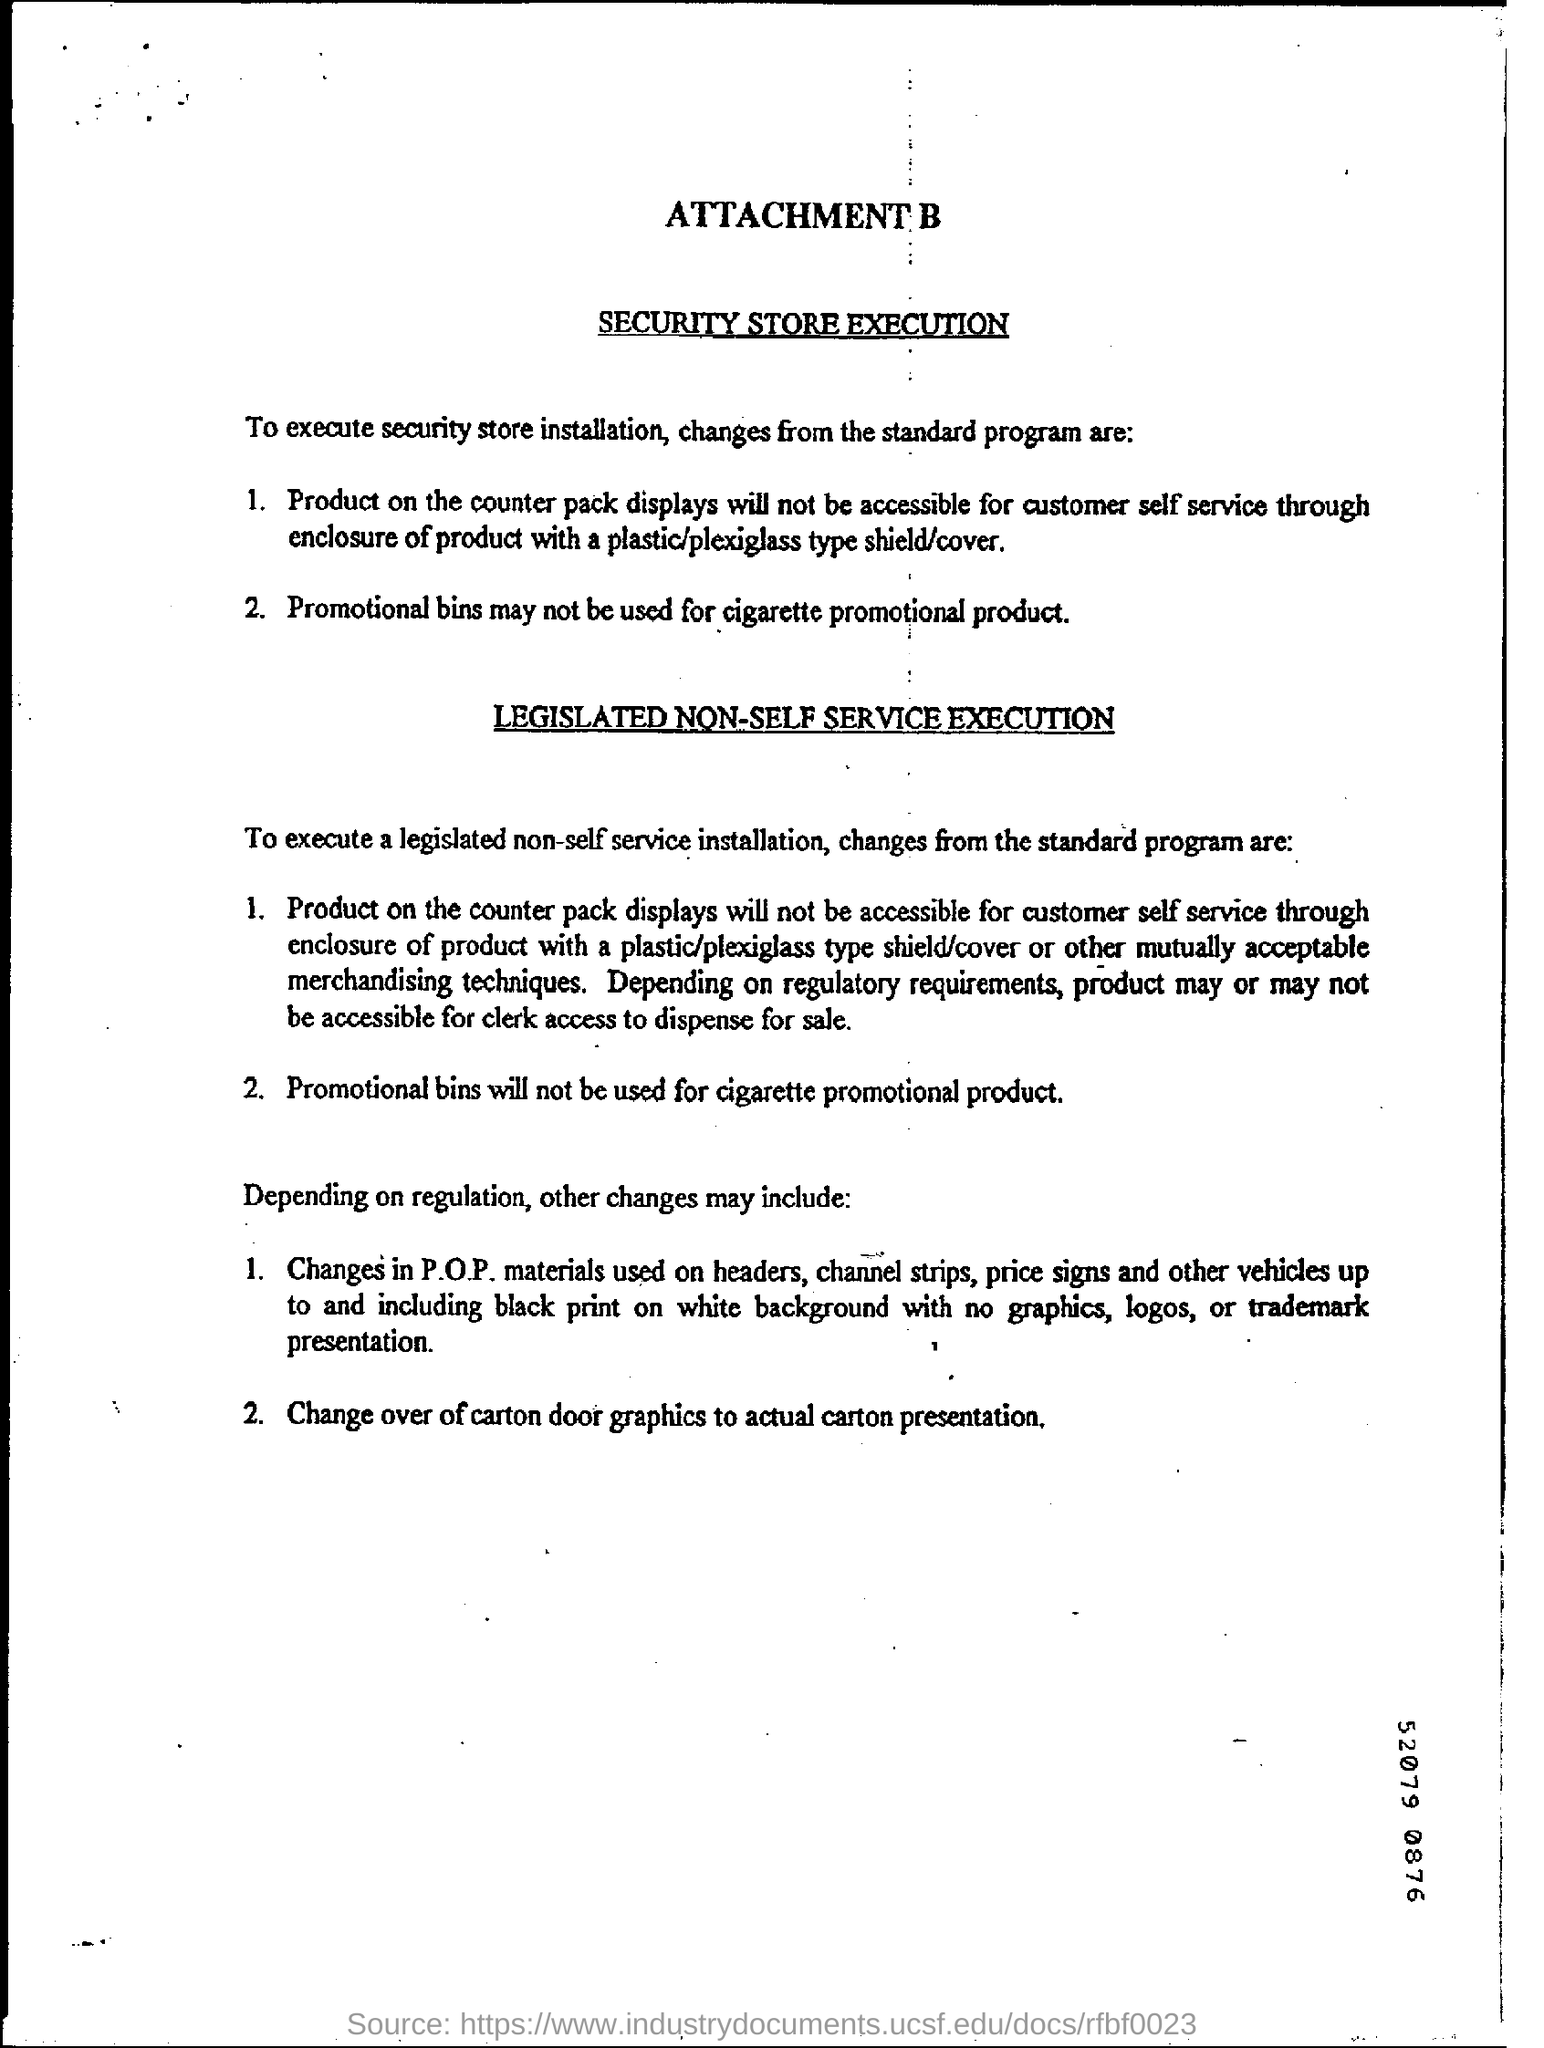What is digit shown at the bottom right corner?
Your response must be concise. 52079 0876. 